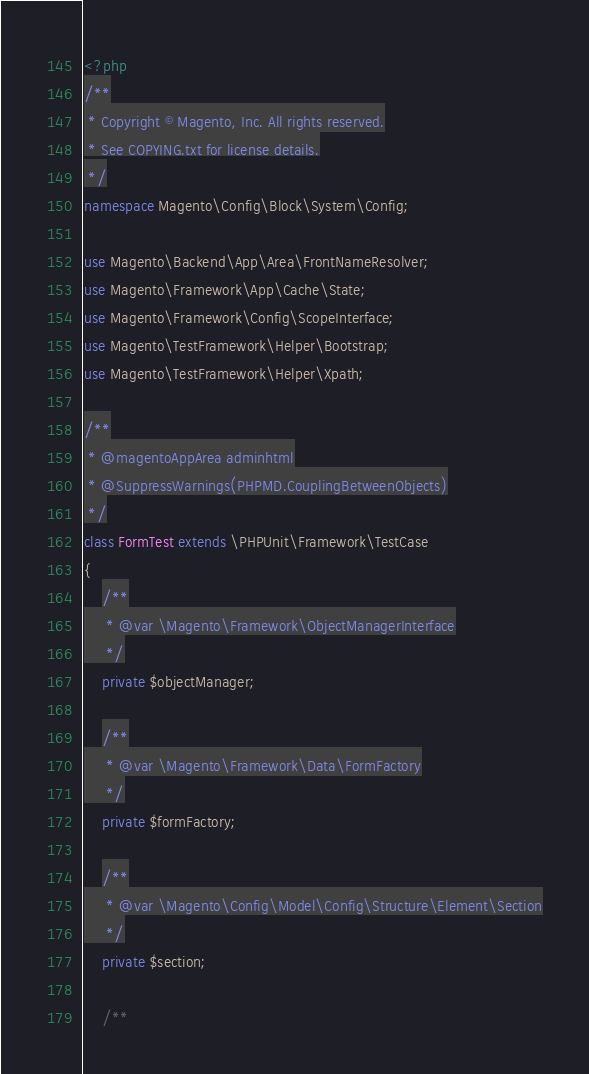<code> <loc_0><loc_0><loc_500><loc_500><_PHP_><?php
/**
 * Copyright © Magento, Inc. All rights reserved.
 * See COPYING.txt for license details.
 */
namespace Magento\Config\Block\System\Config;

use Magento\Backend\App\Area\FrontNameResolver;
use Magento\Framework\App\Cache\State;
use Magento\Framework\Config\ScopeInterface;
use Magento\TestFramework\Helper\Bootstrap;
use Magento\TestFramework\Helper\Xpath;

/**
 * @magentoAppArea adminhtml
 * @SuppressWarnings(PHPMD.CouplingBetweenObjects)
 */
class FormTest extends \PHPUnit\Framework\TestCase
{
    /**
     * @var \Magento\Framework\ObjectManagerInterface
     */
    private $objectManager;

    /**
     * @var \Magento\Framework\Data\FormFactory
     */
    private $formFactory;

    /**
     * @var \Magento\Config\Model\Config\Structure\Element\Section
     */
    private $section;

    /**</code> 